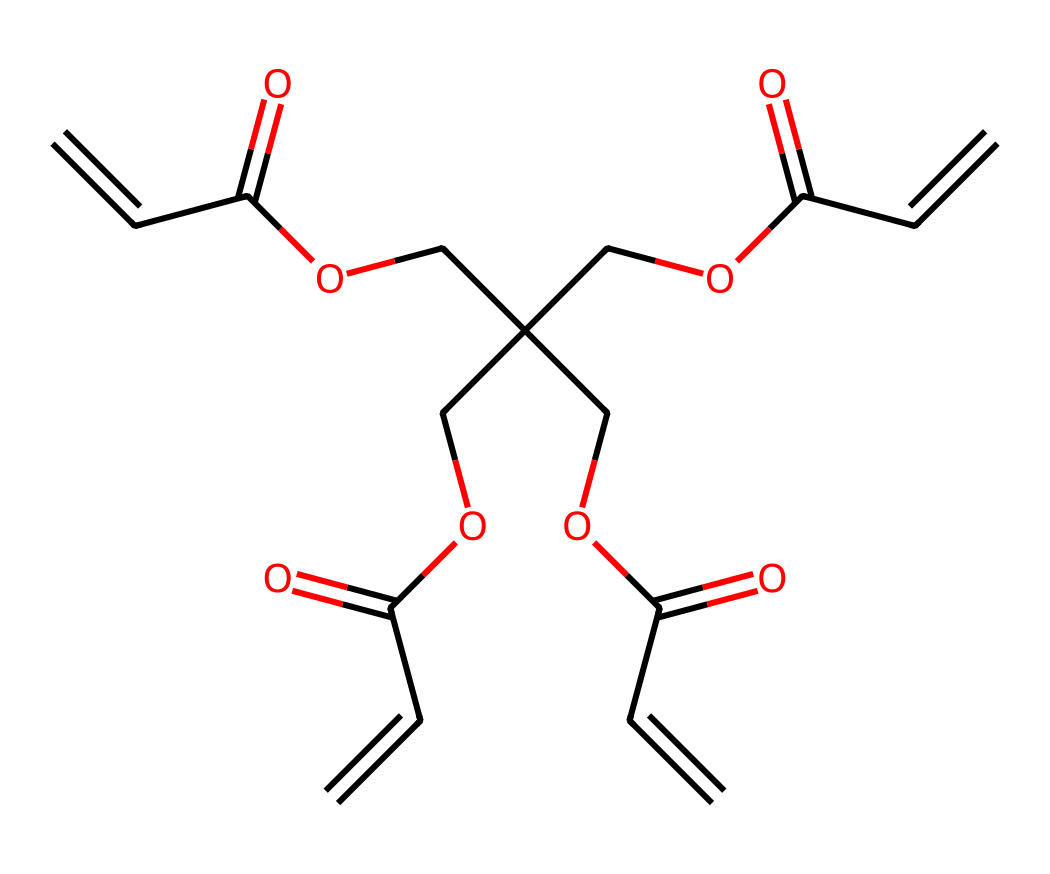How many carbon atoms are in the molecule? The SMILES representation can be analyzed to count the number of carbon atoms (C). Each 'C' in the SMILES corresponds to one carbon atom. By examining the entire structure, we find there are 12 carbon atoms.
Answer: twelve What is the molecular functional group present in this structure? In the SMILES representation, the presence of 'C(=O)O' indicates the presence of carboxylic acid functional groups. This is a characteristic feature in many negative photoresists.
Answer: carboxylic acid How many double bonds are there in the molecule? The notation 'C=C' in the SMILES denotes a double bond between carbon atoms. By analyzing the structure, we find there are a total of four double bonds in the molecule.
Answer: four What characteristic of negative photoresists is evident from this molecular structure? The branched structure and the presence of unsaturated bonds (C=C) imply that this molecule can undergo polymerization upon exposure to light, a critical feature of negative photoresists.
Answer: light sensitivity Which part of the molecule contributes to its solubility in organic solvents? The presence of large alkyl groups, as seen in the chains connecting to 'C(=O)O' units, typically contributes to the solubility of photoresists in organic solvents, enhancing functionality.
Answer: alkyl groups How does this photoresist react when exposed to light? When exposed to light, the double bonds in the structure enable cross-linking reactions to occur, making the exposed areas insoluble, a defining characteristic of negative photoresists which allows for pattern formation.
Answer: cross-linking reaction 